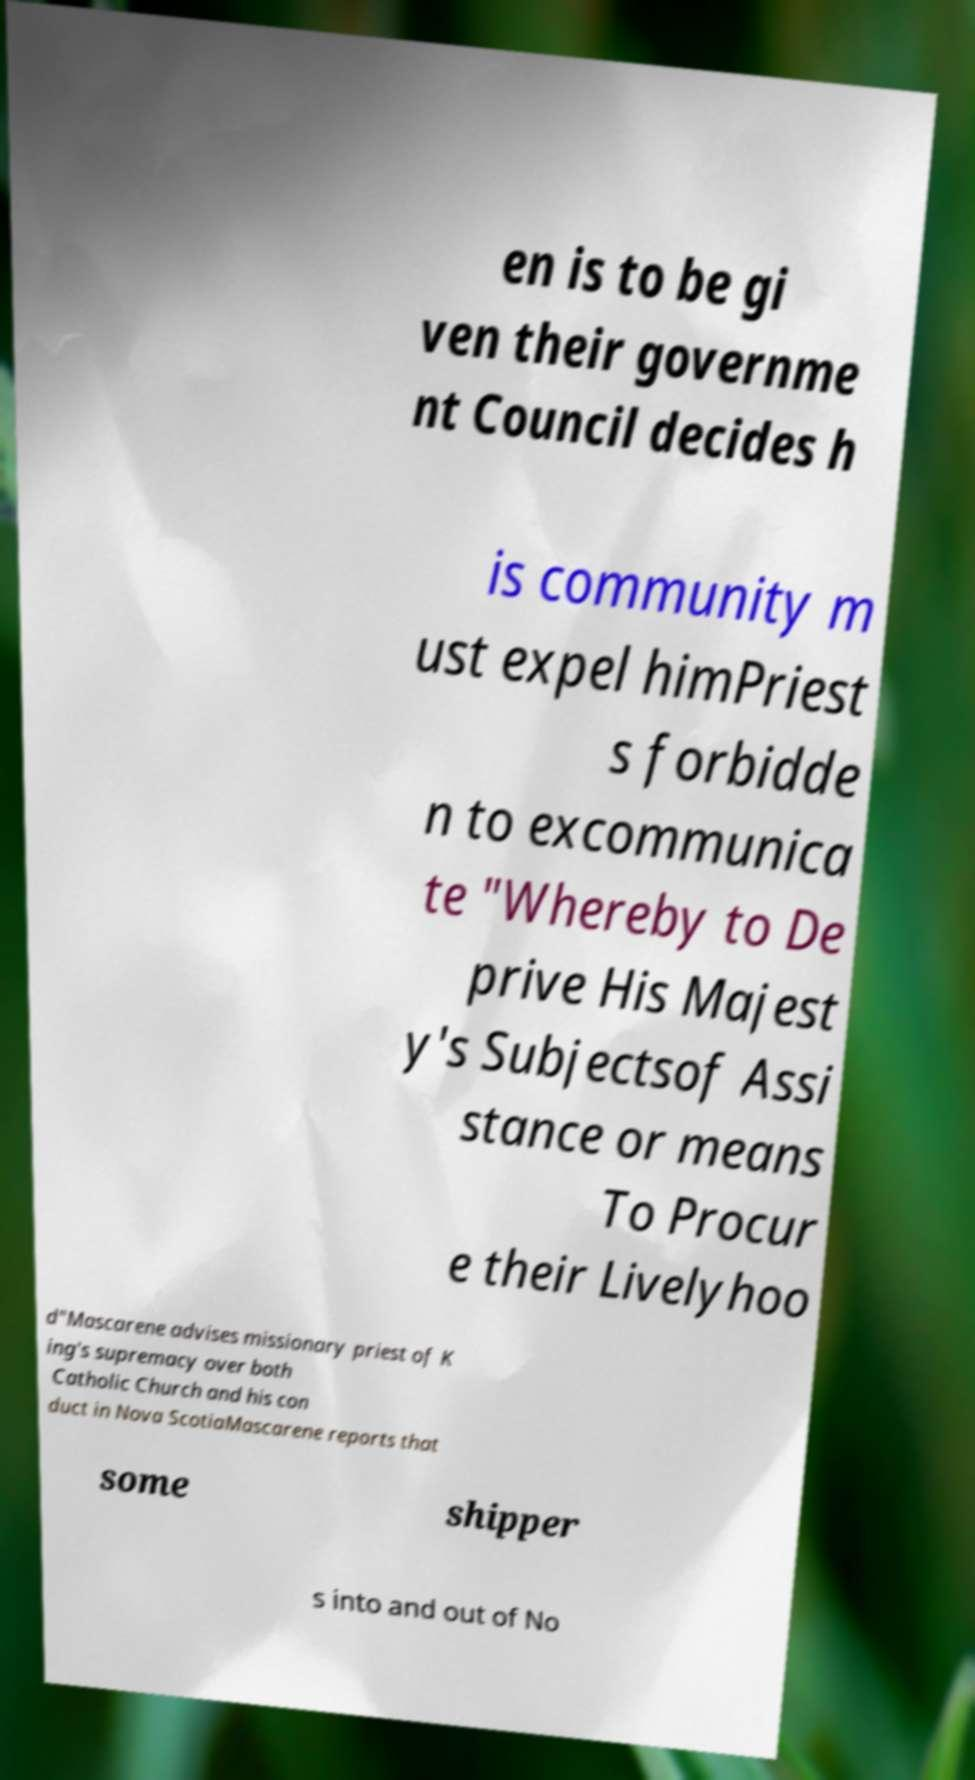For documentation purposes, I need the text within this image transcribed. Could you provide that? en is to be gi ven their governme nt Council decides h is community m ust expel himPriest s forbidde n to excommunica te "Whereby to De prive His Majest y's Subjectsof Assi stance or means To Procur e their Livelyhoo d"Mascarene advises missionary priest of K ing's supremacy over both Catholic Church and his con duct in Nova ScotiaMascarene reports that some shipper s into and out of No 